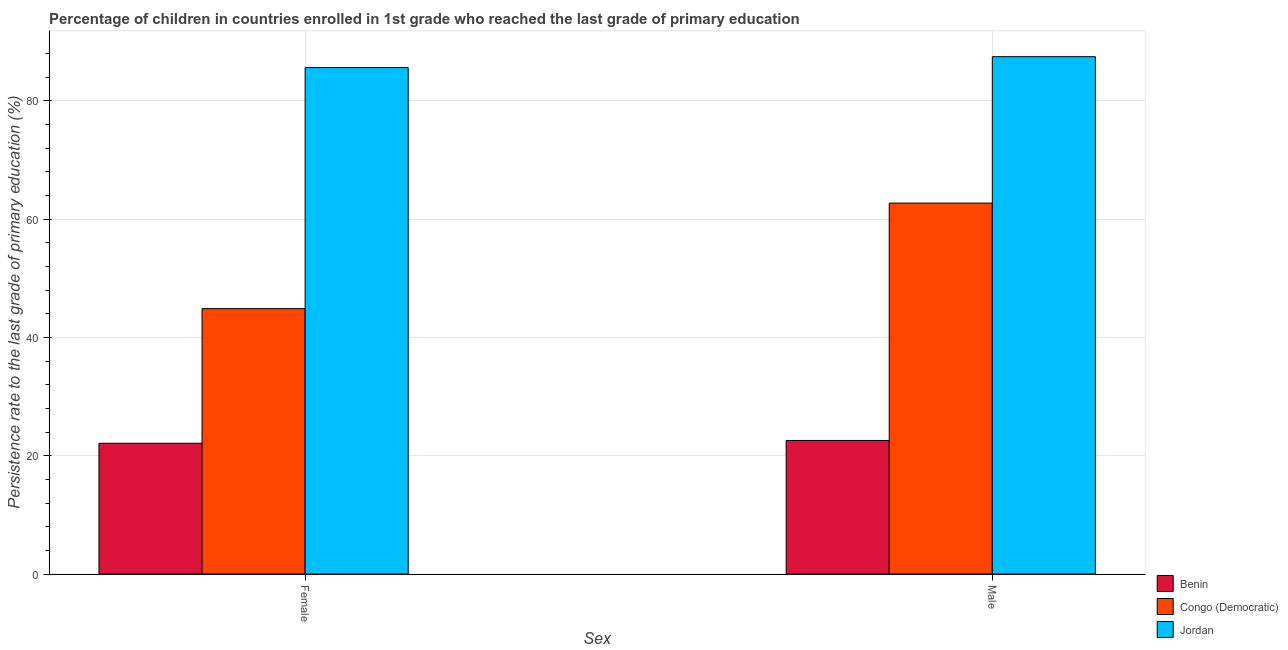How many different coloured bars are there?
Make the answer very short. 3. How many groups of bars are there?
Make the answer very short. 2. How many bars are there on the 2nd tick from the left?
Offer a terse response. 3. How many bars are there on the 1st tick from the right?
Make the answer very short. 3. What is the label of the 2nd group of bars from the left?
Your answer should be compact. Male. What is the persistence rate of male students in Jordan?
Your answer should be compact. 87.49. Across all countries, what is the maximum persistence rate of female students?
Provide a short and direct response. 85.64. Across all countries, what is the minimum persistence rate of male students?
Ensure brevity in your answer.  22.58. In which country was the persistence rate of male students maximum?
Ensure brevity in your answer.  Jordan. In which country was the persistence rate of male students minimum?
Give a very brief answer. Benin. What is the total persistence rate of female students in the graph?
Your response must be concise. 152.64. What is the difference between the persistence rate of male students in Congo (Democratic) and that in Benin?
Your answer should be very brief. 40.15. What is the difference between the persistence rate of male students in Jordan and the persistence rate of female students in Congo (Democratic)?
Offer a very short reply. 42.61. What is the average persistence rate of male students per country?
Provide a short and direct response. 57.6. What is the difference between the persistence rate of female students and persistence rate of male students in Benin?
Give a very brief answer. -0.47. In how many countries, is the persistence rate of female students greater than 76 %?
Your answer should be compact. 1. What is the ratio of the persistence rate of male students in Congo (Democratic) to that in Benin?
Your answer should be very brief. 2.78. Is the persistence rate of female students in Jordan less than that in Congo (Democratic)?
Provide a succinct answer. No. In how many countries, is the persistence rate of female students greater than the average persistence rate of female students taken over all countries?
Make the answer very short. 1. What does the 3rd bar from the left in Male represents?
Provide a succinct answer. Jordan. What does the 1st bar from the right in Female represents?
Keep it short and to the point. Jordan. How many bars are there?
Provide a short and direct response. 6. How many countries are there in the graph?
Give a very brief answer. 3. What is the difference between two consecutive major ticks on the Y-axis?
Give a very brief answer. 20. Are the values on the major ticks of Y-axis written in scientific E-notation?
Your answer should be compact. No. Where does the legend appear in the graph?
Provide a short and direct response. Bottom right. What is the title of the graph?
Offer a terse response. Percentage of children in countries enrolled in 1st grade who reached the last grade of primary education. What is the label or title of the X-axis?
Ensure brevity in your answer.  Sex. What is the label or title of the Y-axis?
Give a very brief answer. Persistence rate to the last grade of primary education (%). What is the Persistence rate to the last grade of primary education (%) in Benin in Female?
Provide a succinct answer. 22.11. What is the Persistence rate to the last grade of primary education (%) in Congo (Democratic) in Female?
Offer a terse response. 44.88. What is the Persistence rate to the last grade of primary education (%) of Jordan in Female?
Ensure brevity in your answer.  85.64. What is the Persistence rate to the last grade of primary education (%) in Benin in Male?
Keep it short and to the point. 22.58. What is the Persistence rate to the last grade of primary education (%) in Congo (Democratic) in Male?
Give a very brief answer. 62.73. What is the Persistence rate to the last grade of primary education (%) in Jordan in Male?
Give a very brief answer. 87.49. Across all Sex, what is the maximum Persistence rate to the last grade of primary education (%) in Benin?
Ensure brevity in your answer.  22.58. Across all Sex, what is the maximum Persistence rate to the last grade of primary education (%) of Congo (Democratic)?
Your answer should be compact. 62.73. Across all Sex, what is the maximum Persistence rate to the last grade of primary education (%) in Jordan?
Make the answer very short. 87.49. Across all Sex, what is the minimum Persistence rate to the last grade of primary education (%) of Benin?
Keep it short and to the point. 22.11. Across all Sex, what is the minimum Persistence rate to the last grade of primary education (%) of Congo (Democratic)?
Ensure brevity in your answer.  44.88. Across all Sex, what is the minimum Persistence rate to the last grade of primary education (%) in Jordan?
Your response must be concise. 85.64. What is the total Persistence rate to the last grade of primary education (%) of Benin in the graph?
Make the answer very short. 44.7. What is the total Persistence rate to the last grade of primary education (%) in Congo (Democratic) in the graph?
Your answer should be very brief. 107.61. What is the total Persistence rate to the last grade of primary education (%) of Jordan in the graph?
Give a very brief answer. 173.13. What is the difference between the Persistence rate to the last grade of primary education (%) in Benin in Female and that in Male?
Your answer should be very brief. -0.47. What is the difference between the Persistence rate to the last grade of primary education (%) in Congo (Democratic) in Female and that in Male?
Provide a succinct answer. -17.85. What is the difference between the Persistence rate to the last grade of primary education (%) in Jordan in Female and that in Male?
Offer a terse response. -1.84. What is the difference between the Persistence rate to the last grade of primary education (%) in Benin in Female and the Persistence rate to the last grade of primary education (%) in Congo (Democratic) in Male?
Ensure brevity in your answer.  -40.61. What is the difference between the Persistence rate to the last grade of primary education (%) in Benin in Female and the Persistence rate to the last grade of primary education (%) in Jordan in Male?
Give a very brief answer. -65.37. What is the difference between the Persistence rate to the last grade of primary education (%) in Congo (Democratic) in Female and the Persistence rate to the last grade of primary education (%) in Jordan in Male?
Your response must be concise. -42.61. What is the average Persistence rate to the last grade of primary education (%) in Benin per Sex?
Make the answer very short. 22.35. What is the average Persistence rate to the last grade of primary education (%) of Congo (Democratic) per Sex?
Your response must be concise. 53.8. What is the average Persistence rate to the last grade of primary education (%) in Jordan per Sex?
Offer a very short reply. 86.57. What is the difference between the Persistence rate to the last grade of primary education (%) of Benin and Persistence rate to the last grade of primary education (%) of Congo (Democratic) in Female?
Offer a very short reply. -22.77. What is the difference between the Persistence rate to the last grade of primary education (%) in Benin and Persistence rate to the last grade of primary education (%) in Jordan in Female?
Your answer should be compact. -63.53. What is the difference between the Persistence rate to the last grade of primary education (%) of Congo (Democratic) and Persistence rate to the last grade of primary education (%) of Jordan in Female?
Offer a very short reply. -40.76. What is the difference between the Persistence rate to the last grade of primary education (%) of Benin and Persistence rate to the last grade of primary education (%) of Congo (Democratic) in Male?
Your response must be concise. -40.15. What is the difference between the Persistence rate to the last grade of primary education (%) of Benin and Persistence rate to the last grade of primary education (%) of Jordan in Male?
Provide a succinct answer. -64.9. What is the difference between the Persistence rate to the last grade of primary education (%) of Congo (Democratic) and Persistence rate to the last grade of primary education (%) of Jordan in Male?
Provide a short and direct response. -24.76. What is the ratio of the Persistence rate to the last grade of primary education (%) in Benin in Female to that in Male?
Offer a very short reply. 0.98. What is the ratio of the Persistence rate to the last grade of primary education (%) in Congo (Democratic) in Female to that in Male?
Offer a very short reply. 0.72. What is the ratio of the Persistence rate to the last grade of primary education (%) in Jordan in Female to that in Male?
Give a very brief answer. 0.98. What is the difference between the highest and the second highest Persistence rate to the last grade of primary education (%) of Benin?
Provide a succinct answer. 0.47. What is the difference between the highest and the second highest Persistence rate to the last grade of primary education (%) in Congo (Democratic)?
Provide a succinct answer. 17.85. What is the difference between the highest and the second highest Persistence rate to the last grade of primary education (%) of Jordan?
Give a very brief answer. 1.84. What is the difference between the highest and the lowest Persistence rate to the last grade of primary education (%) in Benin?
Your answer should be very brief. 0.47. What is the difference between the highest and the lowest Persistence rate to the last grade of primary education (%) of Congo (Democratic)?
Your response must be concise. 17.85. What is the difference between the highest and the lowest Persistence rate to the last grade of primary education (%) in Jordan?
Provide a succinct answer. 1.84. 